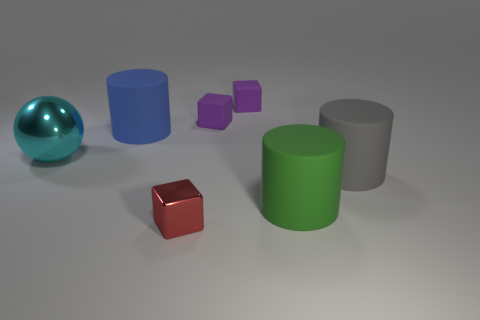What does the arrangement of objects tell us about their potential weights? The arrangement of the objects doesn't provide specific information about their weights. However, we could speculate that, if materials are consistent, the larger objects like the cylinders would likely be heavier due to their higher volume, while the smaller cubes would be lighter. The solitary positions of the objects on the flat surface do not suggest interaction or constraints due to weight. 